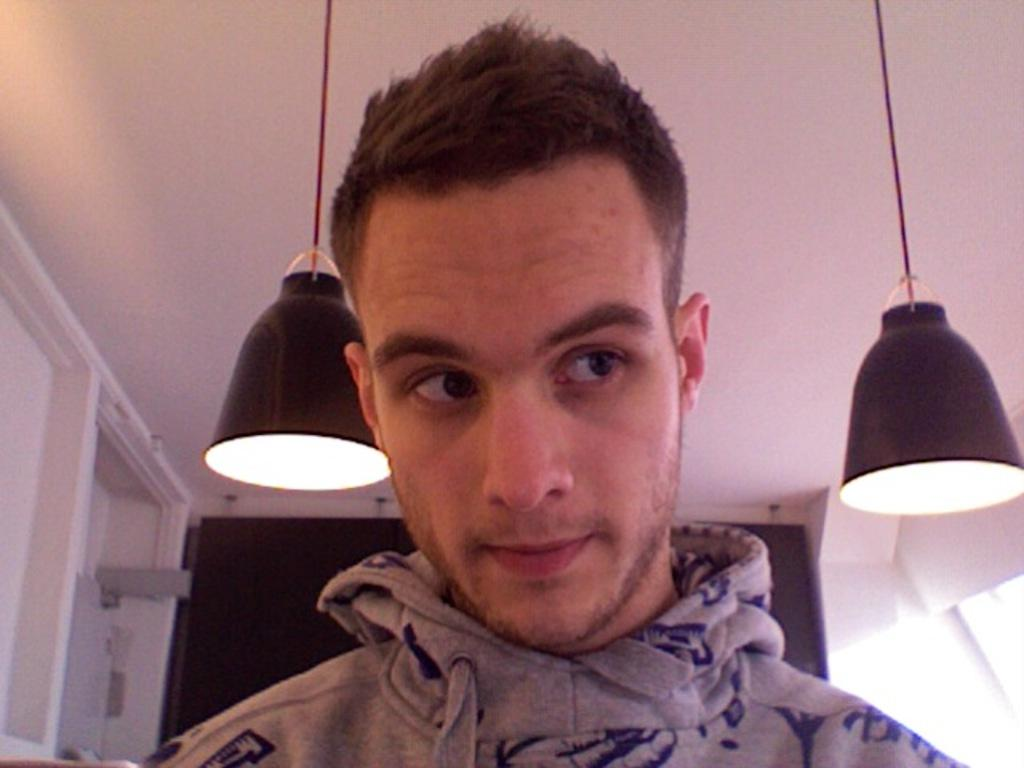Who is present in the image? There is a man in the image. What is the man wearing? The man is wearing an ash-colored hoodie. What can be seen in the image besides the man? There are lightings visible in the image. What is on the wall in the background of the image? There is a blackboard on the wall in the background of the image. What direction is the toad facing in the image? There is no toad present in the image. What type of cheese is on the blackboard in the image? There is no cheese mentioned or visible on the blackboard in the image. 